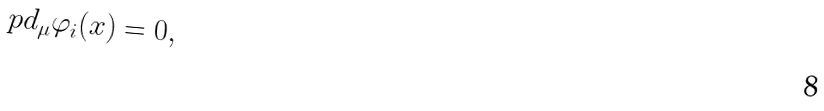<formula> <loc_0><loc_0><loc_500><loc_500>\ p d _ { \mu } \varphi _ { i } ( x ) = 0 ,</formula> 